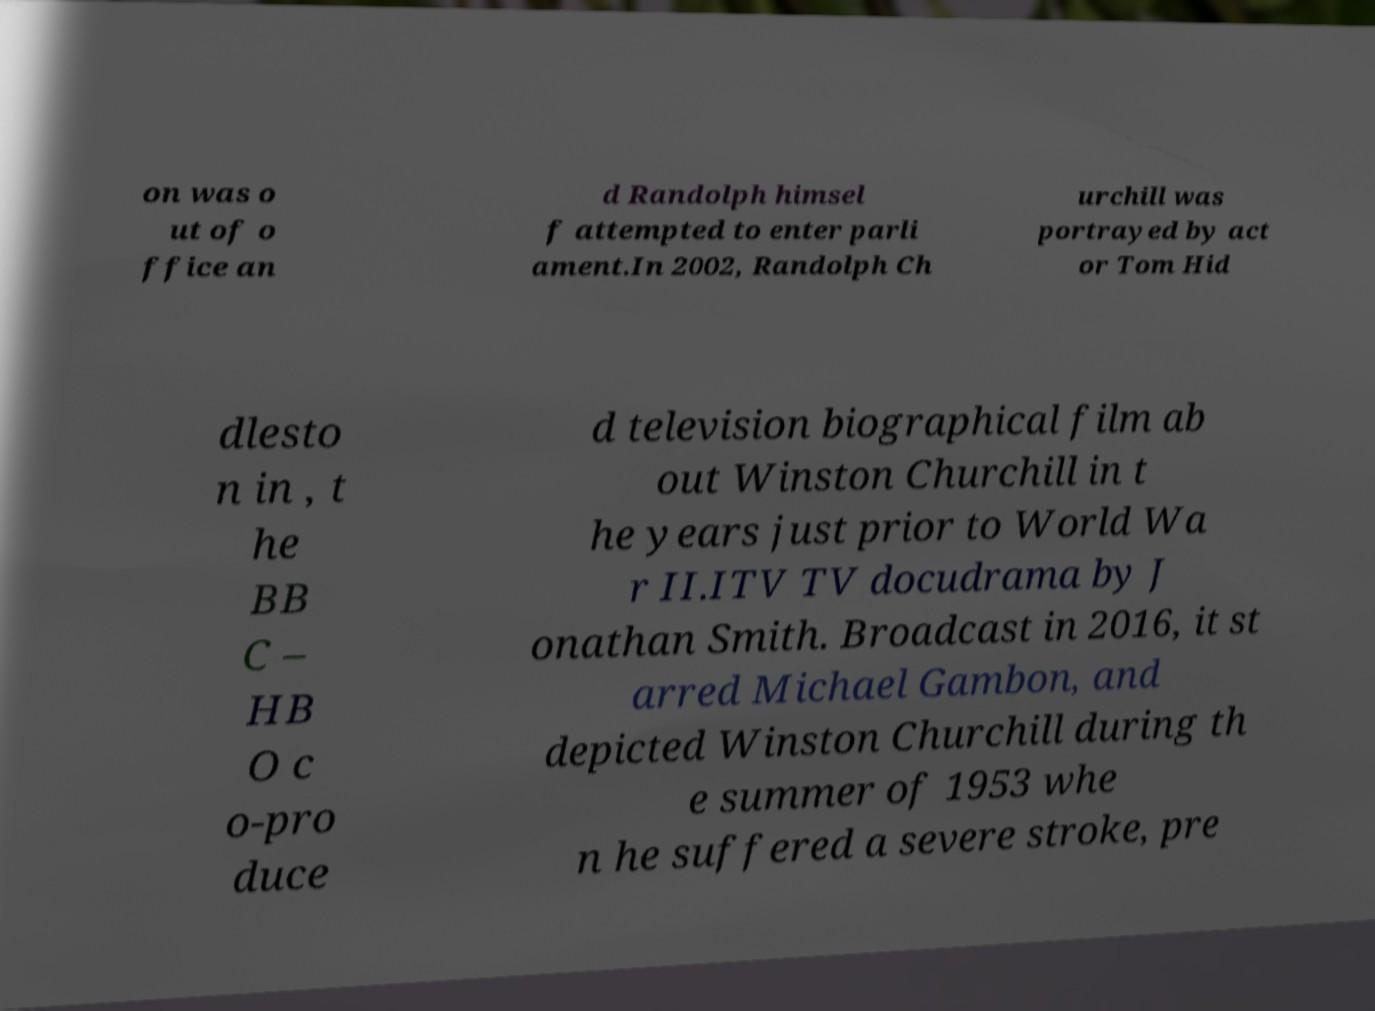Can you accurately transcribe the text from the provided image for me? on was o ut of o ffice an d Randolph himsel f attempted to enter parli ament.In 2002, Randolph Ch urchill was portrayed by act or Tom Hid dlesto n in , t he BB C – HB O c o-pro duce d television biographical film ab out Winston Churchill in t he years just prior to World Wa r II.ITV TV docudrama by J onathan Smith. Broadcast in 2016, it st arred Michael Gambon, and depicted Winston Churchill during th e summer of 1953 whe n he suffered a severe stroke, pre 